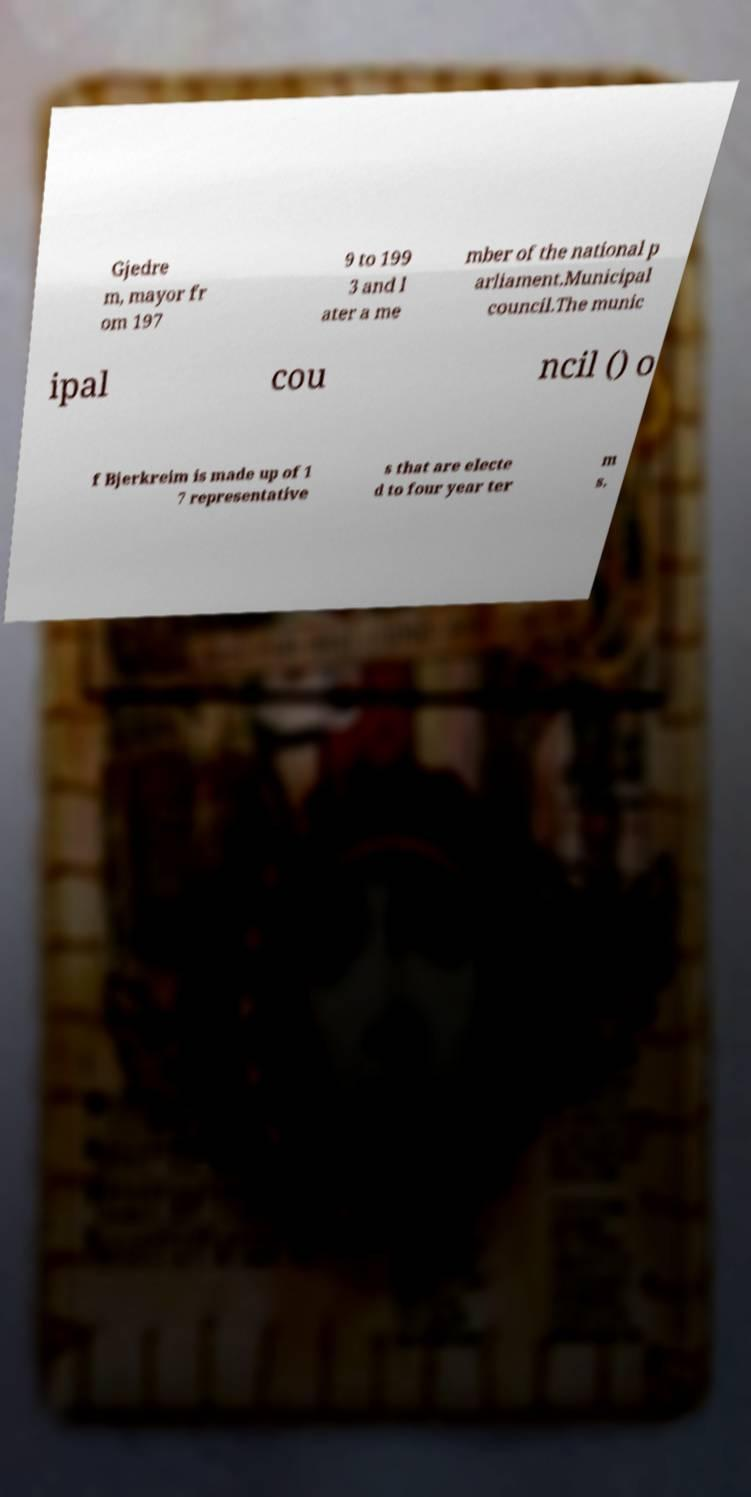Please identify and transcribe the text found in this image. Gjedre m, mayor fr om 197 9 to 199 3 and l ater a me mber of the national p arliament.Municipal council.The munic ipal cou ncil () o f Bjerkreim is made up of 1 7 representative s that are electe d to four year ter m s. 